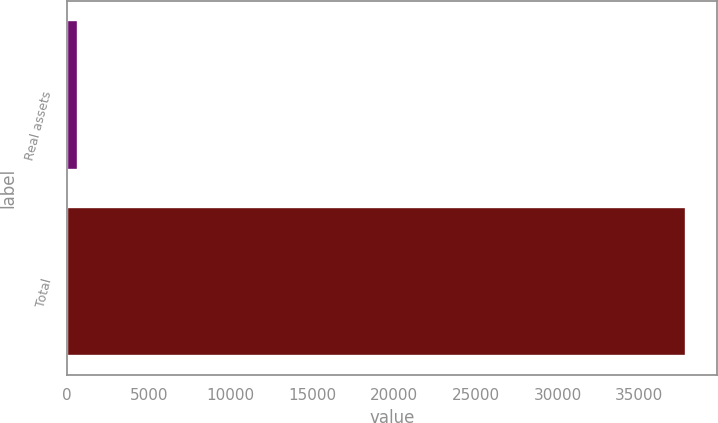Convert chart to OTSL. <chart><loc_0><loc_0><loc_500><loc_500><bar_chart><fcel>Real assets<fcel>Total<nl><fcel>672<fcel>37866<nl></chart> 